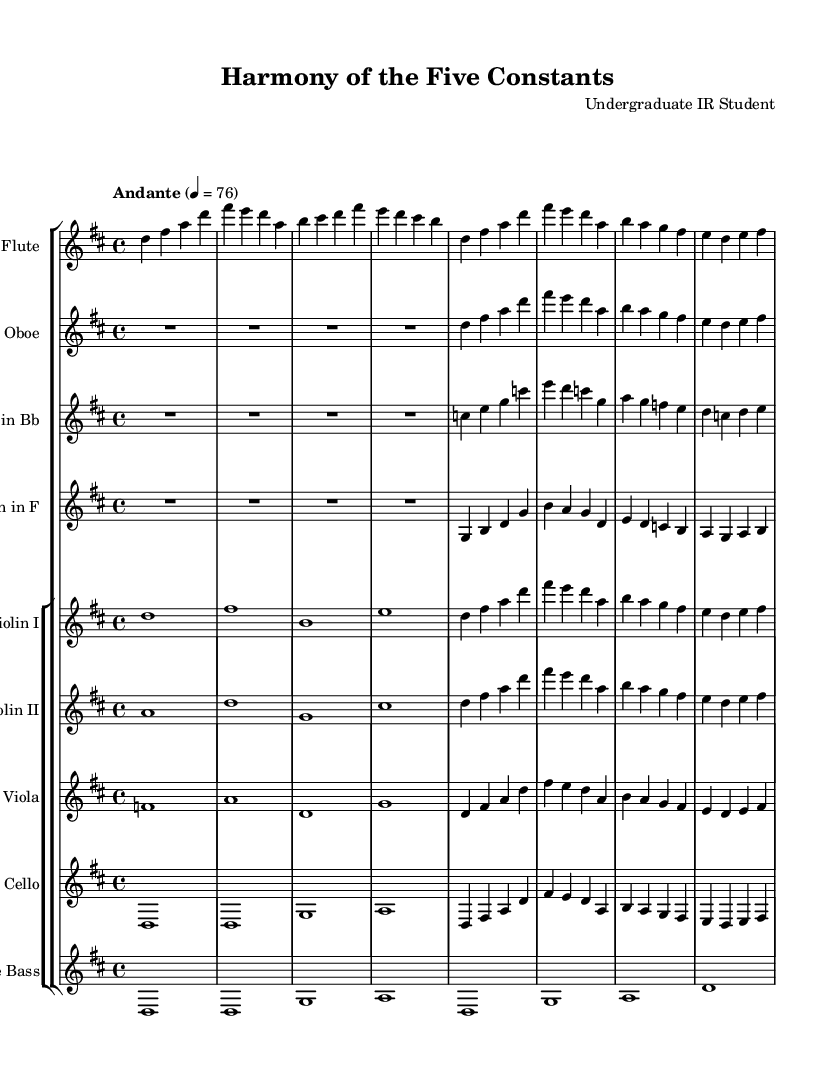What is the key signature of this music? The key signature is indicated at the beginning of the sheet music and shows two sharps, which signifies D major.
Answer: D major What is the time signature of this music? The time signature is indicated right under the key signature and shows 4/4, meaning there are four beats in each measure.
Answer: 4/4 What is the tempo marking for this piece? The tempo marking is found at the beginning of the music, stating "Andante" with a metronome marking of 76 beats per minute.
Answer: Andante, 76 How many instruments are featured in this orchestral arrangement? By counting the individual staves in the score, I see there are nine instruments listed: flute, oboe, clarinet, horn, violin I, violin II, viola, cello, and bass.
Answer: Nine instruments Which instrument plays the lowest pitch in this arrangement? The bass is the lowest instrument listed, providing the foundation of the harmony and playing the lowest pitches in the score.
Answer: Bass How many times does the note D occur in the first line of the flute part? By examining the first line of the flute part measure by measure, I can count three occurrences of the note D.
Answer: Three What thematic element is emphasized through the harmony of this piece? The harmony reflects Confucian teachings, emphasizing balance and stability through the use of consistent melodic motifs and intervals.
Answer: Balance and stability 